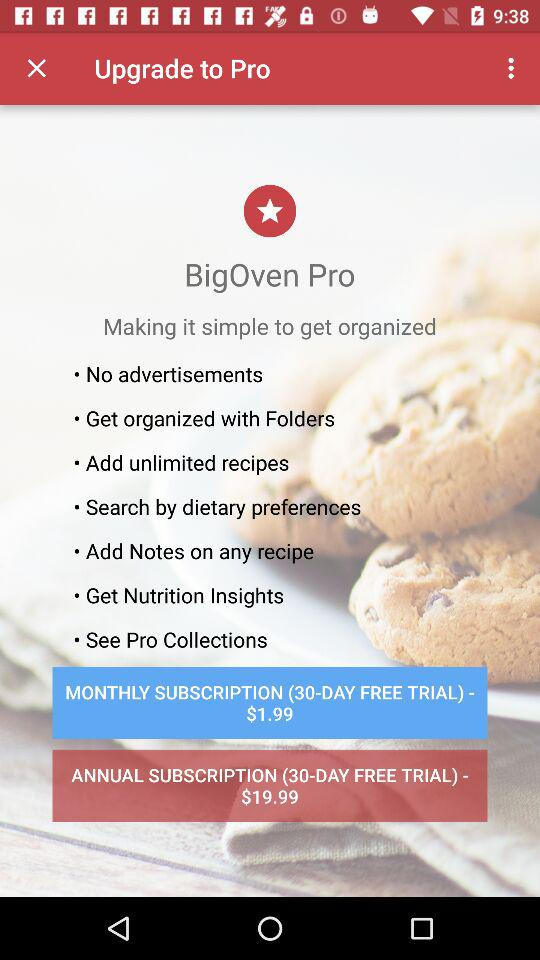What is the monthly subscription price? The monthly subscription price is $1.99. 